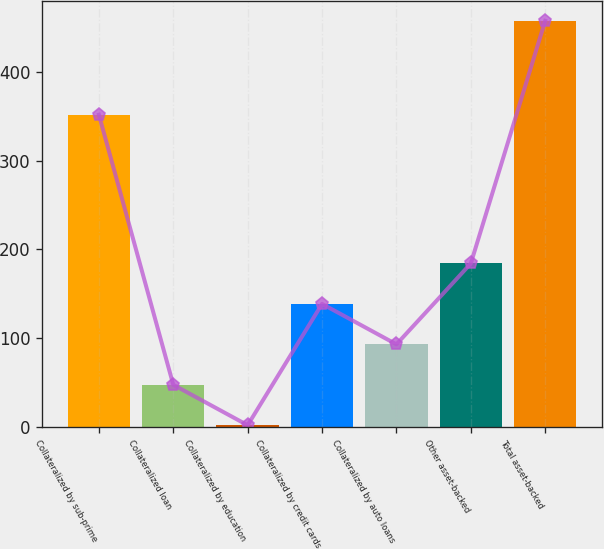<chart> <loc_0><loc_0><loc_500><loc_500><bar_chart><fcel>Collateralized by sub-prime<fcel>Collateralized loan<fcel>Collateralized by education<fcel>Collateralized by credit cards<fcel>Collateralized by auto loans<fcel>Other asset-backed<fcel>Total asset-backed<nl><fcel>352<fcel>47.11<fcel>1.46<fcel>138.41<fcel>92.76<fcel>184.06<fcel>458<nl></chart> 